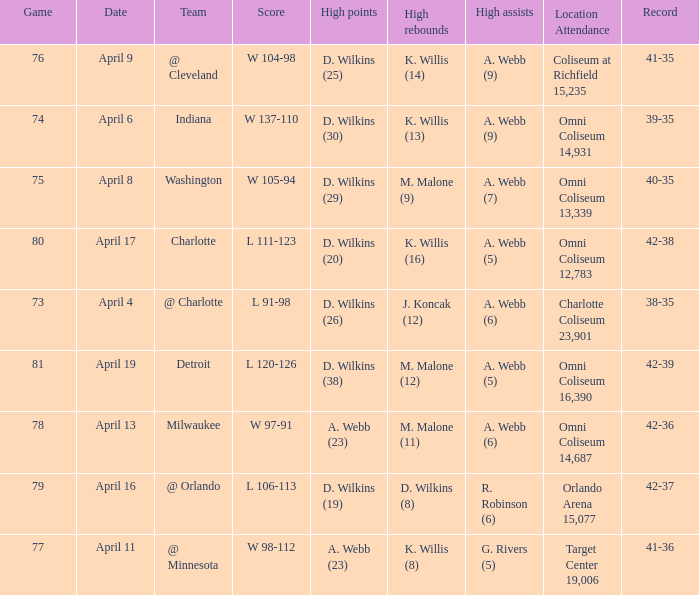Who had the high assists when the opponent was Indiana? A. Webb (9). 